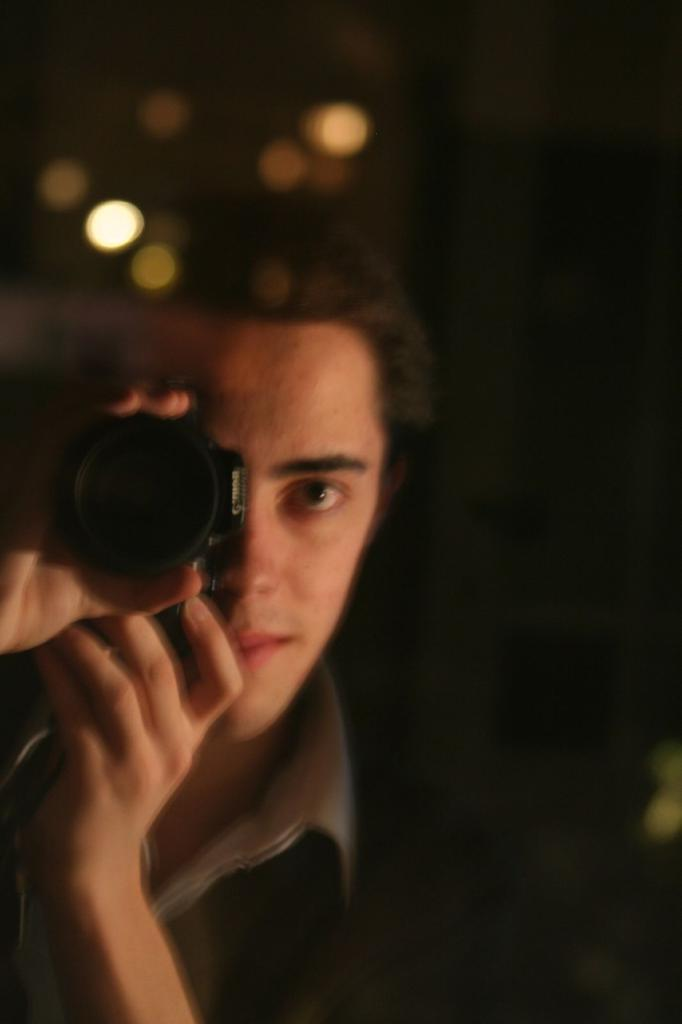What is the main subject of the image? There is a person in the image. What is the person doing in the image? The person is holding a camera near his eye. Are there any additional features in the image? Yes, there are lights on top in the image. How does the person appear in the image? The person is smiling. What type of pest can be seen crawling on the person's shoulder in the image? There is no pest visible on the person's shoulder in the image. What kind of plant is growing near the person in the image? There is no plant present in the image; it only features a person holding a camera and lights on top. 